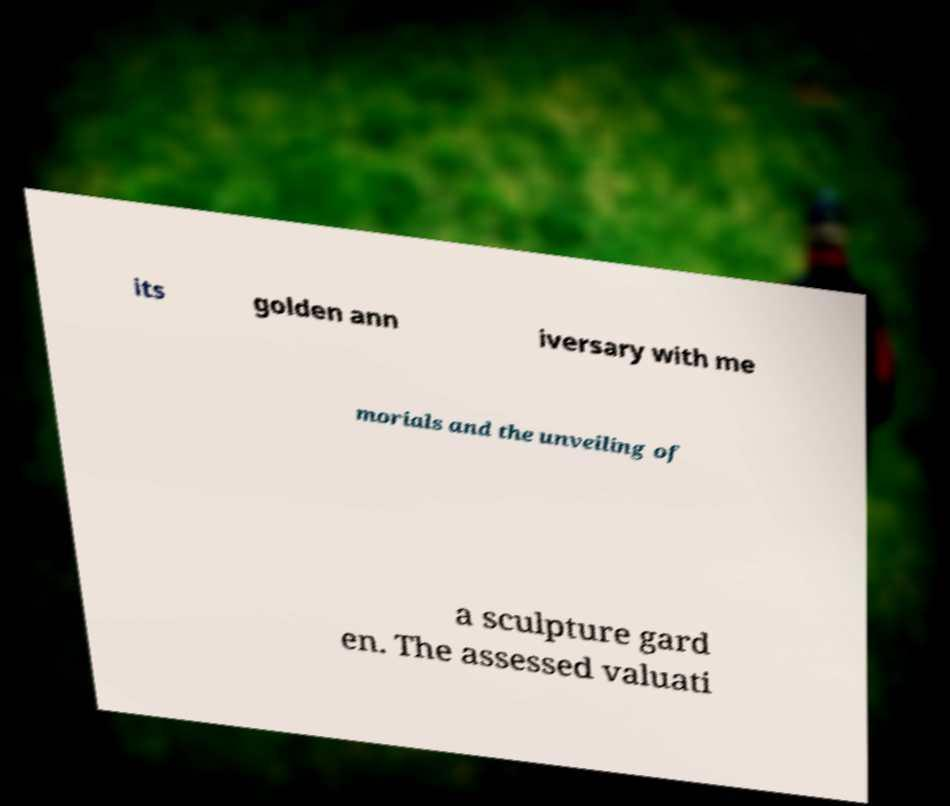Can you read and provide the text displayed in the image?This photo seems to have some interesting text. Can you extract and type it out for me? its golden ann iversary with me morials and the unveiling of a sculpture gard en. The assessed valuati 